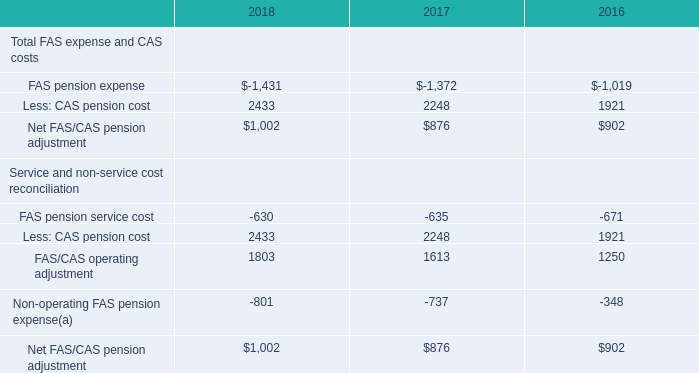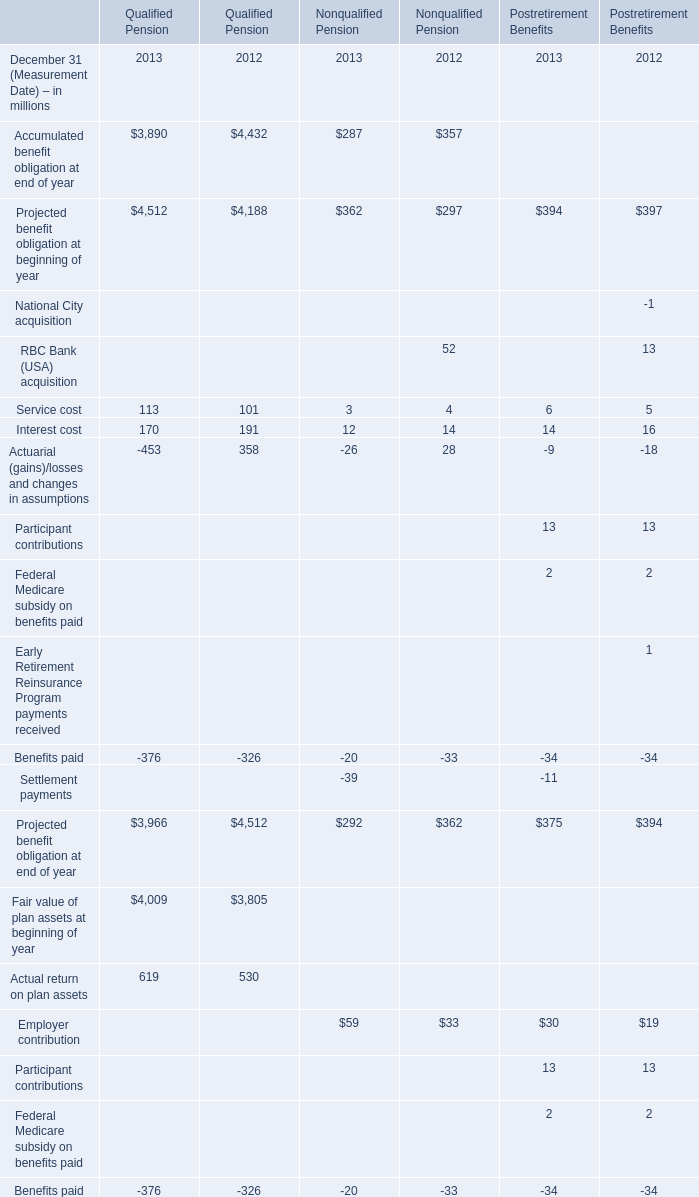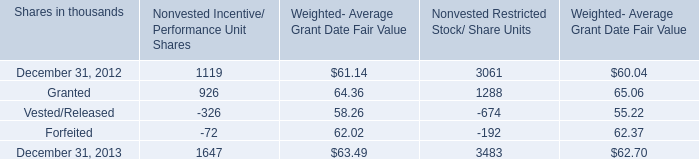What is the average amount of December 31, 2012 of Nonvested Incentive/ Performance Unit Shares, and FAS pension expense of 2016 ? 
Computations: ((1119.0 + 1019.0) / 2)
Answer: 1069.0. 